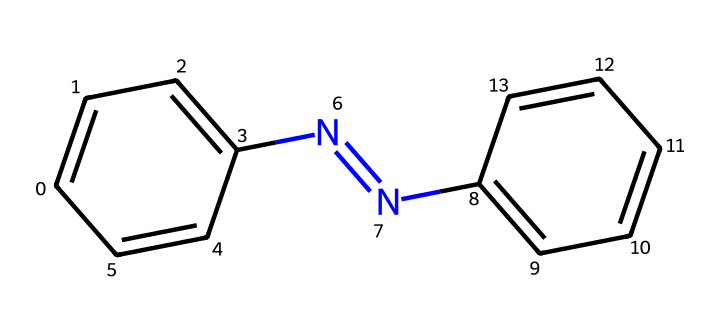What is the molecular formula of this compound? To find the molecular formula, we first count the number of each type of atom in the structure. The compound contains 12 carbon (C) atoms, 10 hydrogen (H) atoms, and 2 nitrogen (N) atoms. Thus, the molecular formula is C12H10N2.
Answer: C12H10N2 How many rings are present in the structure? The structure does not show any cyclic (ring) configurations; all atoms are connected in a linear or branched form. Therefore, there are 0 rings in this compound.
Answer: 0 What type of chemical bond connects the nitrogen atoms? The nitrogen atoms are connected by a double bond, which is indicated in the structure by the "=" notation between the two nitrogen atoms.
Answer: double bond Which functional group is characteristic of this compound? The presence of the N=N double bond indicates that this compound belongs to the azo group, which is a characteristic feature of azobenzene compounds.
Answer: azo group What property allows this compound to be photoreactive? The azo group (N=N) is known for its ability to undergo structural changes when exposed to UV light, allowing it to be photoreactive; this means it can absorb UV radiation and change its structure.
Answer: azo group How many conjugated π bonds are in the structure? By examining the structure, we can see there are three conjugated π bonds: two from the double bonds in the azo group and one from the phenyl rings. This means there are three conjugated π bonds total.
Answer: 3 